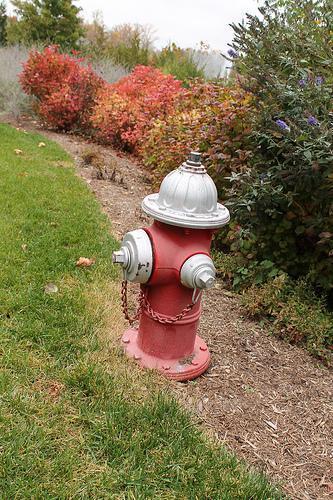How many fire hydrants?
Give a very brief answer. 1. 